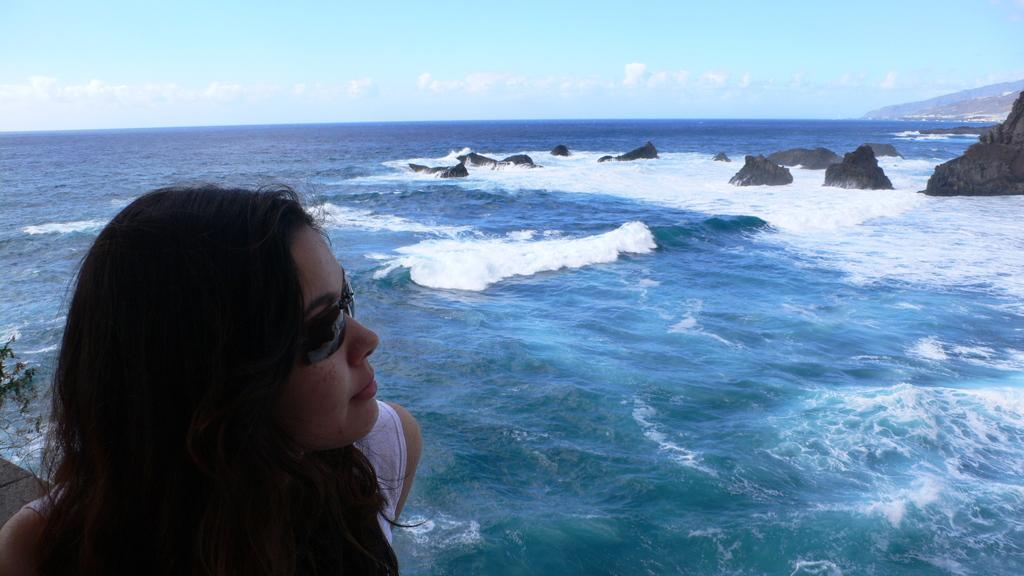What is located on the left side of the image? There is a beautiful woman in the left side of the image. What can be seen in the middle of the image? There is water in the middle of the image. What type of objects are on the right side of the image? There are stones in the right side of the image. How many beds can be seen in the image? There are no beds present in the image. What does the woman's tongue look like in the image? There is no information about the woman's tongue in the image. 